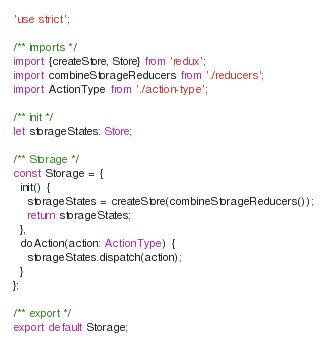Convert code to text. <code><loc_0><loc_0><loc_500><loc_500><_TypeScript_>'use strict';

/** imports */
import {createStore, Store} from 'redux';
import combineStorageReducers from './reducers';
import ActionType from './action-type';

/** init */
let storageStates: Store;

/** Storage */
const Storage = {
  init() {
    storageStates = createStore(combineStorageReducers());
    return storageStates;
  },
  doAction(action: ActionType) {
    storageStates.dispatch(action);
  }
};

/** export */
export default Storage;</code> 